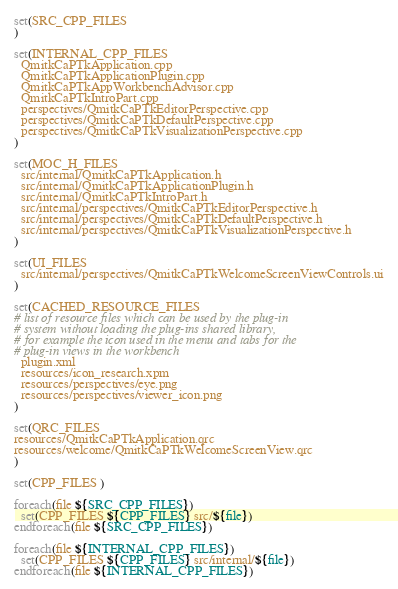<code> <loc_0><loc_0><loc_500><loc_500><_CMake_>set(SRC_CPP_FILES
)

set(INTERNAL_CPP_FILES
  QmitkCaPTkApplication.cpp
  QmitkCaPTkApplicationPlugin.cpp
  QmitkCaPTkAppWorkbenchAdvisor.cpp
  QmitkCaPTkIntroPart.cpp
  perspectives/QmitkCaPTkEditorPerspective.cpp
  perspectives/QmitkCaPTkDefaultPerspective.cpp
  perspectives/QmitkCaPTkVisualizationPerspective.cpp
)

set(MOC_H_FILES
  src/internal/QmitkCaPTkApplication.h
  src/internal/QmitkCaPTkApplicationPlugin.h
  src/internal/QmitkCaPTkIntroPart.h
  src/internal/perspectives/QmitkCaPTkEditorPerspective.h
  src/internal/perspectives/QmitkCaPTkDefaultPerspective.h
  src/internal/perspectives/QmitkCaPTkVisualizationPerspective.h
)

set(UI_FILES
  src/internal/perspectives/QmitkCaPTkWelcomeScreenViewControls.ui
)

set(CACHED_RESOURCE_FILES
# list of resource files which can be used by the plug-in
# system without loading the plug-ins shared library,
# for example the icon used in the menu and tabs for the
# plug-in views in the workbench
  plugin.xml
  resources/icon_research.xpm
  resources/perspectives/eye.png
  resources/perspectives/viewer_icon.png
)

set(QRC_FILES
resources/QmitkCaPTkApplication.qrc
resources/welcome/QmitkCaPTkWelcomeScreenView.qrc
)

set(CPP_FILES )

foreach(file ${SRC_CPP_FILES})
  set(CPP_FILES ${CPP_FILES} src/${file})
endforeach(file ${SRC_CPP_FILES})

foreach(file ${INTERNAL_CPP_FILES})
  set(CPP_FILES ${CPP_FILES} src/internal/${file})
endforeach(file ${INTERNAL_CPP_FILES})

</code> 